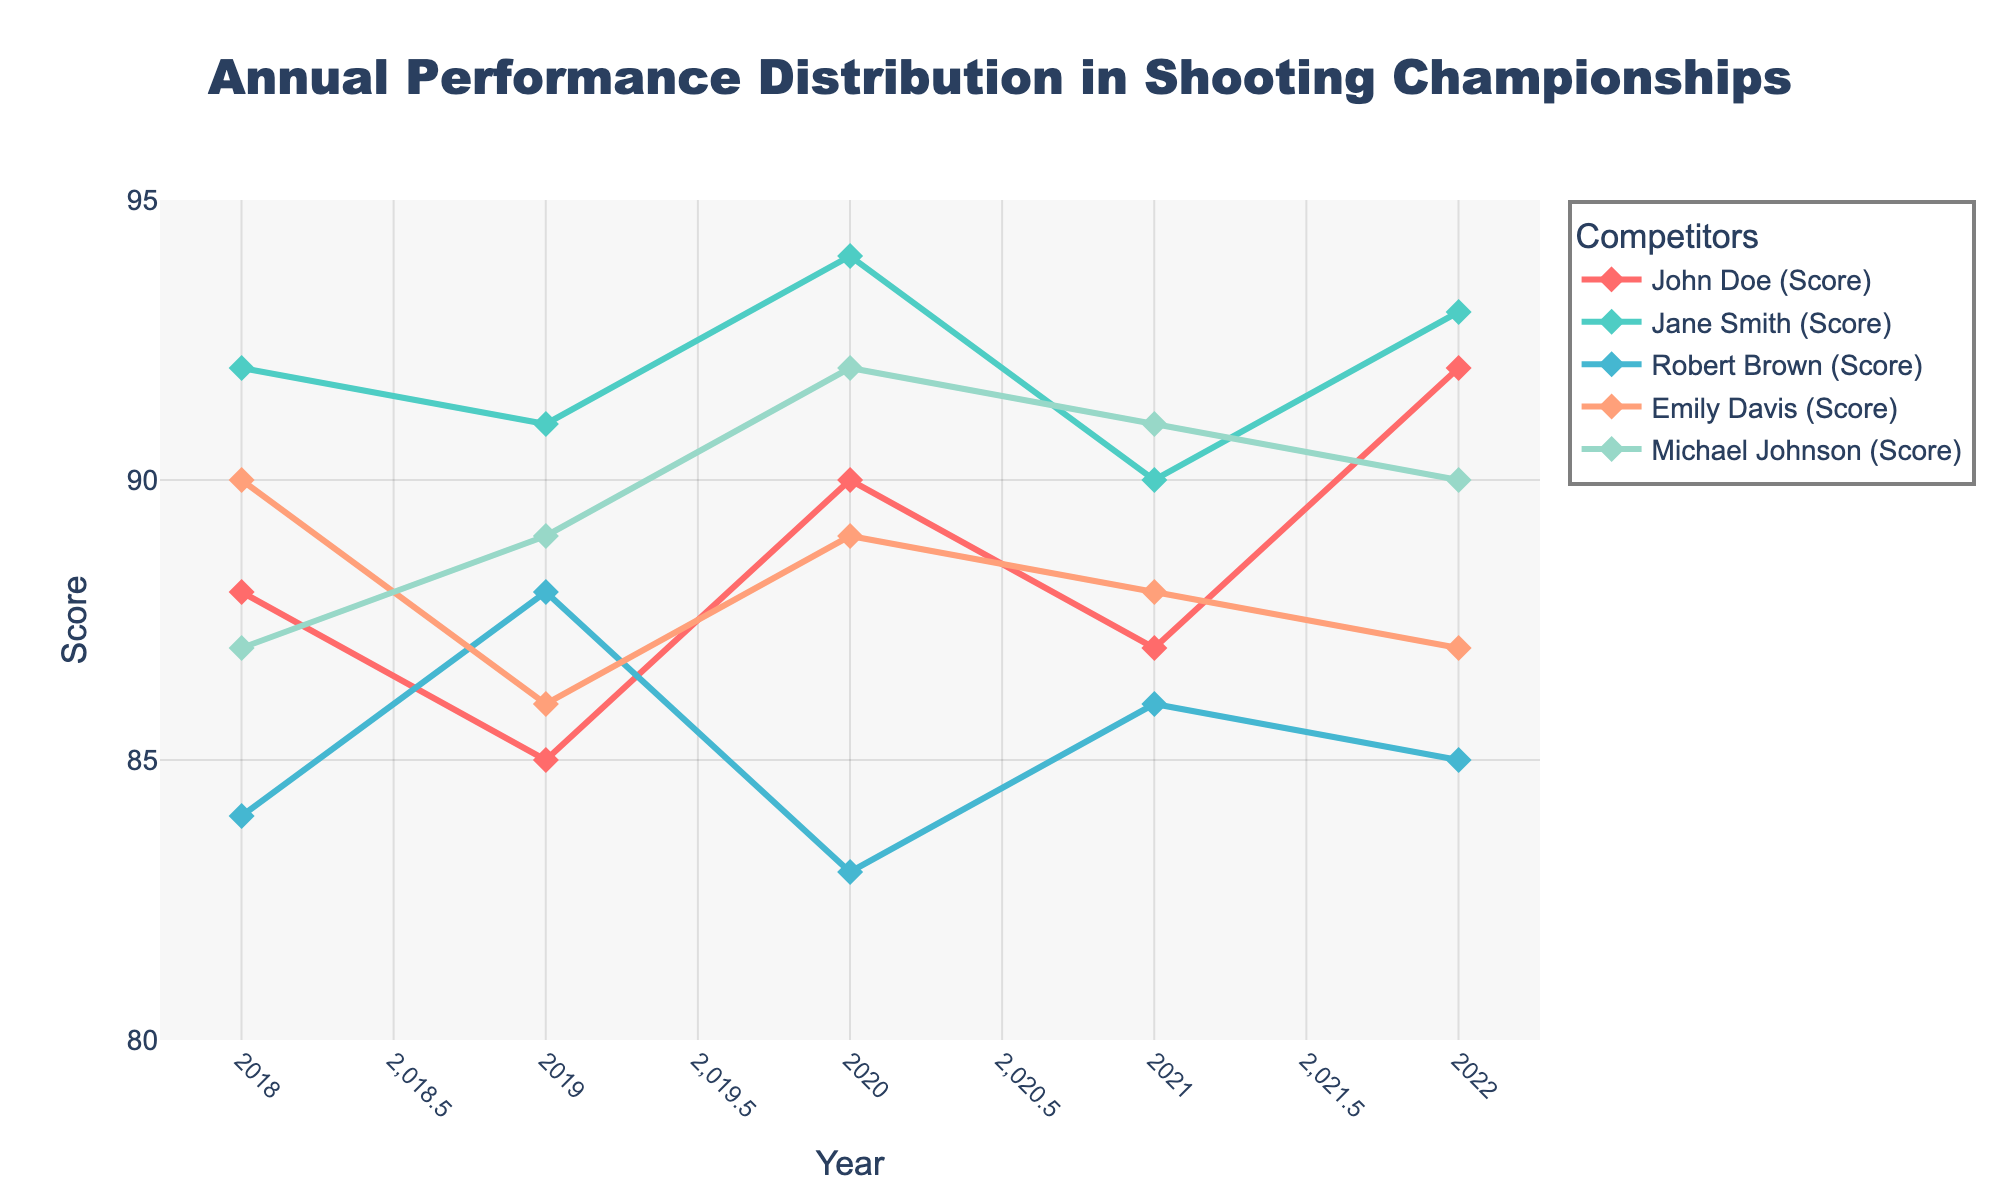What is the title of the plot? The title of the plot is located at the top and typically describes the overall content of the figure. In this case, it should be "Annual Performance Distribution in Shooting Championships".
Answer: Annual Performance Distribution in Shooting Championships What does the x-axis represent in the plot? The x-axis at the bottom of the plot represents the different years in which the competition data was recorded.
Answer: Year Which competitor has the highest score in the year 2020? Look for the series corresponding to each competitor for the year 2020 and find the one with the maximum value. Here, the highest score is recorded by Jane Smith with a score of 94.
Answer: Jane Smith Between which years did John Doe's score increase the most? Identify the score for John Doe for each year and calculate the difference between each consecutive year's scores. The largest increase is between 2019 (85) and 2020 (90), giving an increase of 5 points.
Answer: Between 2019 and 2020 What was the average performance score of Emily Davis from 2018 to 2022? Add up Emily Davis's scores for each year and divide by the total number of years (5). (90 + 86 + 89 + 88 + 87) / 5 = 88
Answer: 88 In which year did Michael Johnson score the lowest, and what was the score? Check Michael Johnson's scores for each year and identify the minimum value. The lowest score is in 2018 with a score of 87.
Answer: 2018, 87 How does Robert Brown's performance trend over the years? Observe the line for Robert Brown's scores over the years. Note that scores fluctuate but do not show a consistent upward or downward trend. Specifically: 84 in 2018, 88 in 2019, 83 in 2020, 86 in 2021, and 85 in 2022.
Answer: Fluctuating trend If you sum the scores for all competitors in 2021, what is the total? Add all the scores for 2021. John Doe (87), Jane Smith (90), Robert Brown (86), Emily Davis (88), and Michael Johnson (91). So, 87 + 90 + 86 + 88 + 91 = 442.
Answer: 442 Which competitor shows the most consistent performance, and how can you tell? To determine consistency, look for the competitor whose scores show the least variation over the years. Jane Smith shows high consistency with scores closely grouped: 92, 91, 94, 90, 93.
Answer: Jane Smith Which year had the most number of competitors scoring above 90? Count the number of competitors scoring above 90 for each year. For 2018, 1 competitor; for 2019, 0; for 2020, 2; for 2021, 1; for 2022, 3. The highest count is for 2022.
Answer: 2022 